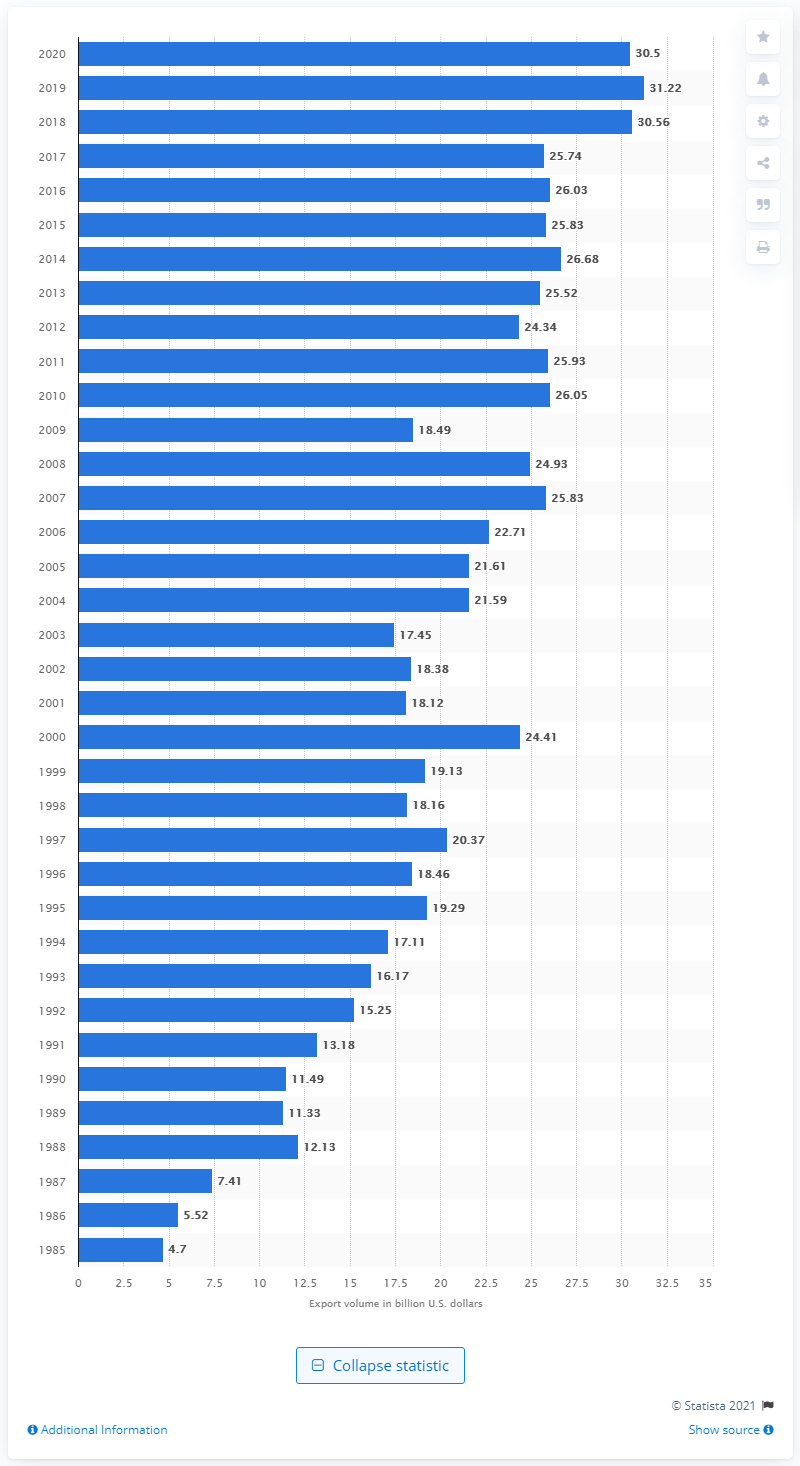Highlight a few significant elements in this photo. In 2020, the value of U.S. exports to Taiwan was 30.5 billion dollars. 